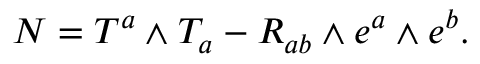Convert formula to latex. <formula><loc_0><loc_0><loc_500><loc_500>N = T ^ { a } \wedge T _ { a } - R _ { a b } \wedge e ^ { a } \wedge e ^ { b } .</formula> 